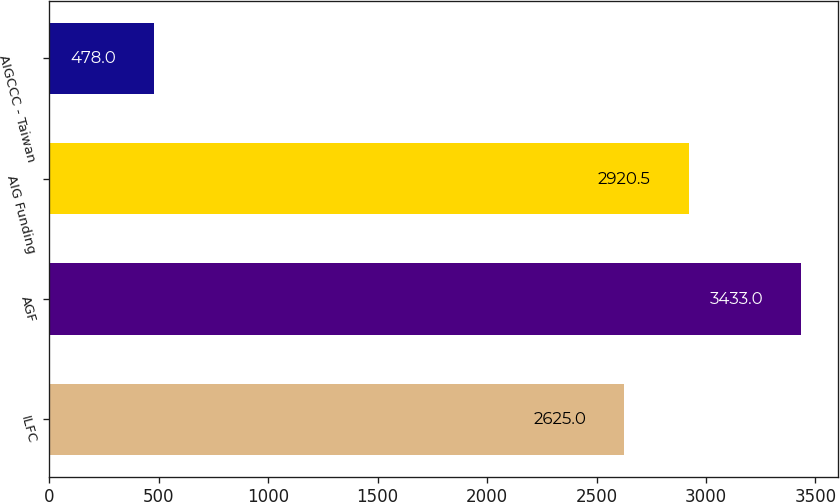Convert chart. <chart><loc_0><loc_0><loc_500><loc_500><bar_chart><fcel>ILFC<fcel>AGF<fcel>AIG Funding<fcel>AIGCCC - Taiwan<nl><fcel>2625<fcel>3433<fcel>2920.5<fcel>478<nl></chart> 